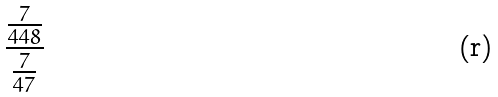Convert formula to latex. <formula><loc_0><loc_0><loc_500><loc_500>\frac { \frac { 7 } { 4 4 8 } } { \frac { 7 } { 4 7 } }</formula> 